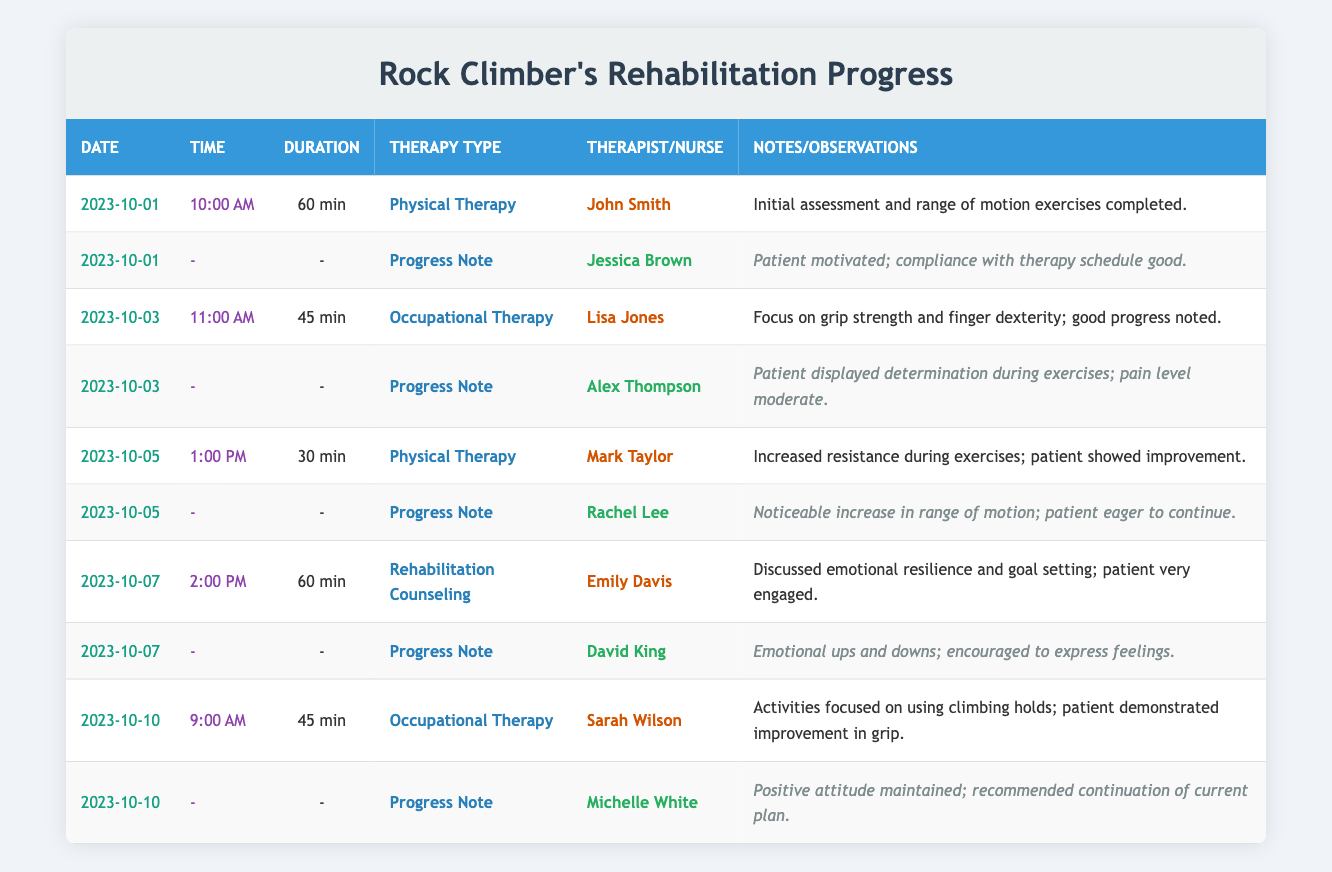What day was the first therapy session held? The first therapy session is on October 1, 2023, as per the session data
Answer: October 1, 2023 Who was the therapist for the occupational therapy session on October 10? Looking at the entry for October 10, it shows that Sarah Wilson was the therapist for the occupational therapy session
Answer: Sarah Wilson How many total minutes of therapy sessions were conducted? The minutes for each session are as follows: 60, 45, 30, 60, and 45, summing these gives (60 + 45 + 30 + 60 + 45) = 240 minutes of therapy
Answer: 240 minutes Was there a progress note on October 5? Yes, there is a progress note for October 5, recorded by Rachel Lee, which states there was a noticeable increase in range of motion
Answer: Yes What is the average duration of the therapy sessions in minutes? The durations of the therapy sessions are 60, 45, 30, 60, and 45 minutes. Adding these gives 240 minutes, and dividing by the number of sessions (5) gives an average of 240/5 = 48 minutes
Answer: 48 minutes On which date did the patient show notable improvement in grip strength? The session on October 10 focused on using climbing holds where the patient demonstrated improvement in grip strength according to the notes
Answer: October 10 What was the patient's pain level during the session on October 3? Based on the progress note from October 3, the nurse observed that the patient's pain level was moderate during exercises
Answer: Moderate How many different therapists were involved in the therapy sessions? The different therapists mentioned are John Smith, Lisa Jones, Mark Taylor, Emily Davis, and Sarah Wilson. Counting these gives 5 unique therapists involved in therapy sessions
Answer: 5 therapists What observation was noted by the nurse on October 7? The progress note from October 7, recorded by David King, indicates that the patient experienced emotional ups and downs and was encouraged to express feelings
Answer: Emotional ups and downs; encouraged to express feelings 